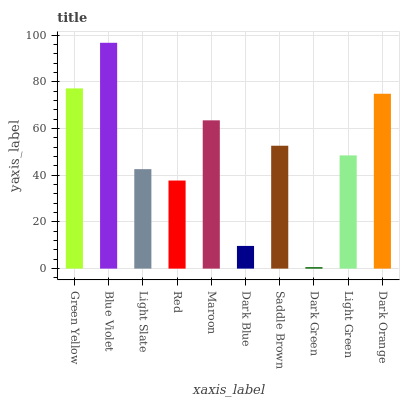Is Dark Green the minimum?
Answer yes or no. Yes. Is Blue Violet the maximum?
Answer yes or no. Yes. Is Light Slate the minimum?
Answer yes or no. No. Is Light Slate the maximum?
Answer yes or no. No. Is Blue Violet greater than Light Slate?
Answer yes or no. Yes. Is Light Slate less than Blue Violet?
Answer yes or no. Yes. Is Light Slate greater than Blue Violet?
Answer yes or no. No. Is Blue Violet less than Light Slate?
Answer yes or no. No. Is Saddle Brown the high median?
Answer yes or no. Yes. Is Light Green the low median?
Answer yes or no. Yes. Is Dark Blue the high median?
Answer yes or no. No. Is Green Yellow the low median?
Answer yes or no. No. 